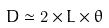Convert formula to latex. <formula><loc_0><loc_0><loc_500><loc_500>D \simeq 2 \times L \times \theta \,</formula> 